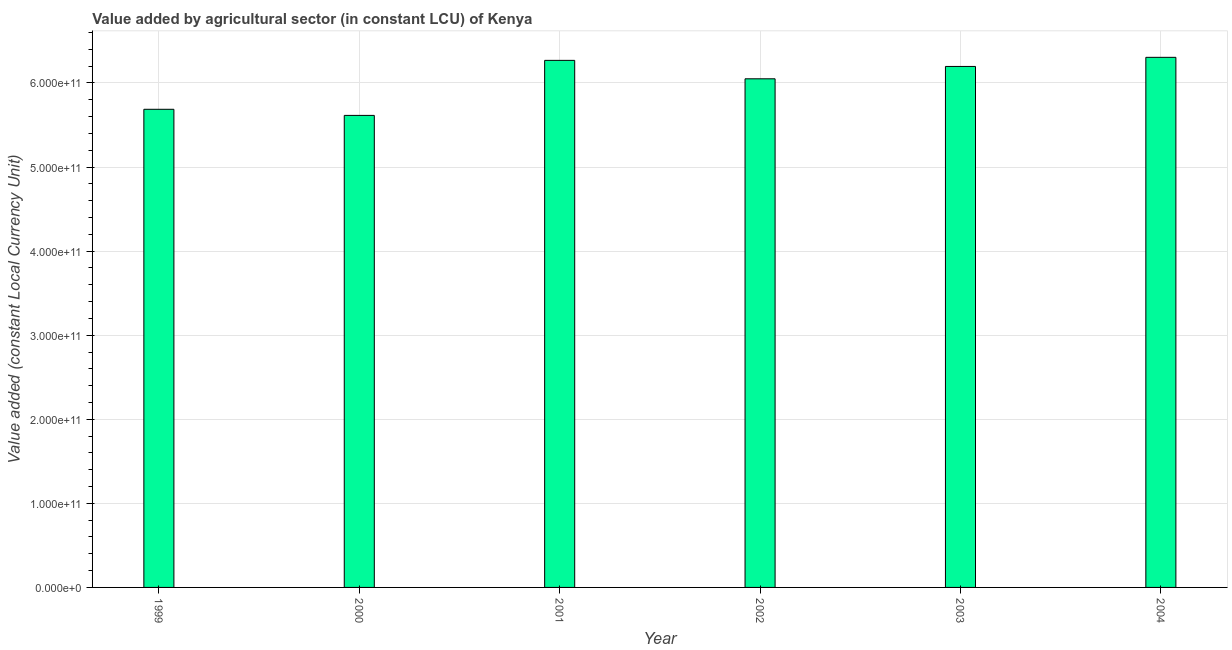Does the graph contain any zero values?
Your answer should be very brief. No. Does the graph contain grids?
Your response must be concise. Yes. What is the title of the graph?
Provide a short and direct response. Value added by agricultural sector (in constant LCU) of Kenya. What is the label or title of the Y-axis?
Your response must be concise. Value added (constant Local Currency Unit). What is the value added by agriculture sector in 2004?
Make the answer very short. 6.31e+11. Across all years, what is the maximum value added by agriculture sector?
Ensure brevity in your answer.  6.31e+11. Across all years, what is the minimum value added by agriculture sector?
Your answer should be compact. 5.61e+11. In which year was the value added by agriculture sector maximum?
Provide a succinct answer. 2004. What is the sum of the value added by agriculture sector?
Your answer should be very brief. 3.61e+12. What is the difference between the value added by agriculture sector in 2000 and 2002?
Make the answer very short. -4.35e+1. What is the average value added by agriculture sector per year?
Provide a succinct answer. 6.02e+11. What is the median value added by agriculture sector?
Offer a terse response. 6.12e+11. In how many years, is the value added by agriculture sector greater than 80000000000 LCU?
Your answer should be very brief. 6. Do a majority of the years between 1999 and 2004 (inclusive) have value added by agriculture sector greater than 440000000000 LCU?
Make the answer very short. Yes. What is the ratio of the value added by agriculture sector in 2000 to that in 2001?
Give a very brief answer. 0.9. What is the difference between the highest and the second highest value added by agriculture sector?
Your response must be concise. 3.62e+09. Is the sum of the value added by agriculture sector in 2002 and 2003 greater than the maximum value added by agriculture sector across all years?
Give a very brief answer. Yes. What is the difference between the highest and the lowest value added by agriculture sector?
Your response must be concise. 6.91e+1. How many bars are there?
Your answer should be compact. 6. What is the difference between two consecutive major ticks on the Y-axis?
Your response must be concise. 1.00e+11. What is the Value added (constant Local Currency Unit) in 1999?
Give a very brief answer. 5.69e+11. What is the Value added (constant Local Currency Unit) of 2000?
Your answer should be very brief. 5.61e+11. What is the Value added (constant Local Currency Unit) of 2001?
Make the answer very short. 6.27e+11. What is the Value added (constant Local Currency Unit) of 2002?
Give a very brief answer. 6.05e+11. What is the Value added (constant Local Currency Unit) of 2003?
Offer a terse response. 6.20e+11. What is the Value added (constant Local Currency Unit) in 2004?
Provide a succinct answer. 6.31e+11. What is the difference between the Value added (constant Local Currency Unit) in 1999 and 2000?
Offer a terse response. 7.26e+09. What is the difference between the Value added (constant Local Currency Unit) in 1999 and 2001?
Make the answer very short. -5.82e+1. What is the difference between the Value added (constant Local Currency Unit) in 1999 and 2002?
Your answer should be compact. -3.63e+1. What is the difference between the Value added (constant Local Currency Unit) in 1999 and 2003?
Your answer should be compact. -5.10e+1. What is the difference between the Value added (constant Local Currency Unit) in 1999 and 2004?
Offer a very short reply. -6.18e+1. What is the difference between the Value added (constant Local Currency Unit) in 2000 and 2001?
Your answer should be very brief. -6.55e+1. What is the difference between the Value added (constant Local Currency Unit) in 2000 and 2002?
Make the answer very short. -4.35e+1. What is the difference between the Value added (constant Local Currency Unit) in 2000 and 2003?
Provide a short and direct response. -5.82e+1. What is the difference between the Value added (constant Local Currency Unit) in 2000 and 2004?
Ensure brevity in your answer.  -6.91e+1. What is the difference between the Value added (constant Local Currency Unit) in 2001 and 2002?
Keep it short and to the point. 2.19e+1. What is the difference between the Value added (constant Local Currency Unit) in 2001 and 2003?
Ensure brevity in your answer.  7.21e+09. What is the difference between the Value added (constant Local Currency Unit) in 2001 and 2004?
Offer a very short reply. -3.62e+09. What is the difference between the Value added (constant Local Currency Unit) in 2002 and 2003?
Your response must be concise. -1.47e+1. What is the difference between the Value added (constant Local Currency Unit) in 2002 and 2004?
Provide a succinct answer. -2.55e+1. What is the difference between the Value added (constant Local Currency Unit) in 2003 and 2004?
Keep it short and to the point. -1.08e+1. What is the ratio of the Value added (constant Local Currency Unit) in 1999 to that in 2001?
Offer a terse response. 0.91. What is the ratio of the Value added (constant Local Currency Unit) in 1999 to that in 2003?
Provide a succinct answer. 0.92. What is the ratio of the Value added (constant Local Currency Unit) in 1999 to that in 2004?
Provide a short and direct response. 0.9. What is the ratio of the Value added (constant Local Currency Unit) in 2000 to that in 2001?
Your answer should be very brief. 0.9. What is the ratio of the Value added (constant Local Currency Unit) in 2000 to that in 2002?
Ensure brevity in your answer.  0.93. What is the ratio of the Value added (constant Local Currency Unit) in 2000 to that in 2003?
Offer a very short reply. 0.91. What is the ratio of the Value added (constant Local Currency Unit) in 2000 to that in 2004?
Offer a terse response. 0.89. What is the ratio of the Value added (constant Local Currency Unit) in 2001 to that in 2002?
Your answer should be very brief. 1.04. What is the ratio of the Value added (constant Local Currency Unit) in 2001 to that in 2003?
Make the answer very short. 1.01. What is the ratio of the Value added (constant Local Currency Unit) in 2001 to that in 2004?
Provide a short and direct response. 0.99. What is the ratio of the Value added (constant Local Currency Unit) in 2002 to that in 2003?
Keep it short and to the point. 0.98. What is the ratio of the Value added (constant Local Currency Unit) in 2003 to that in 2004?
Provide a short and direct response. 0.98. 